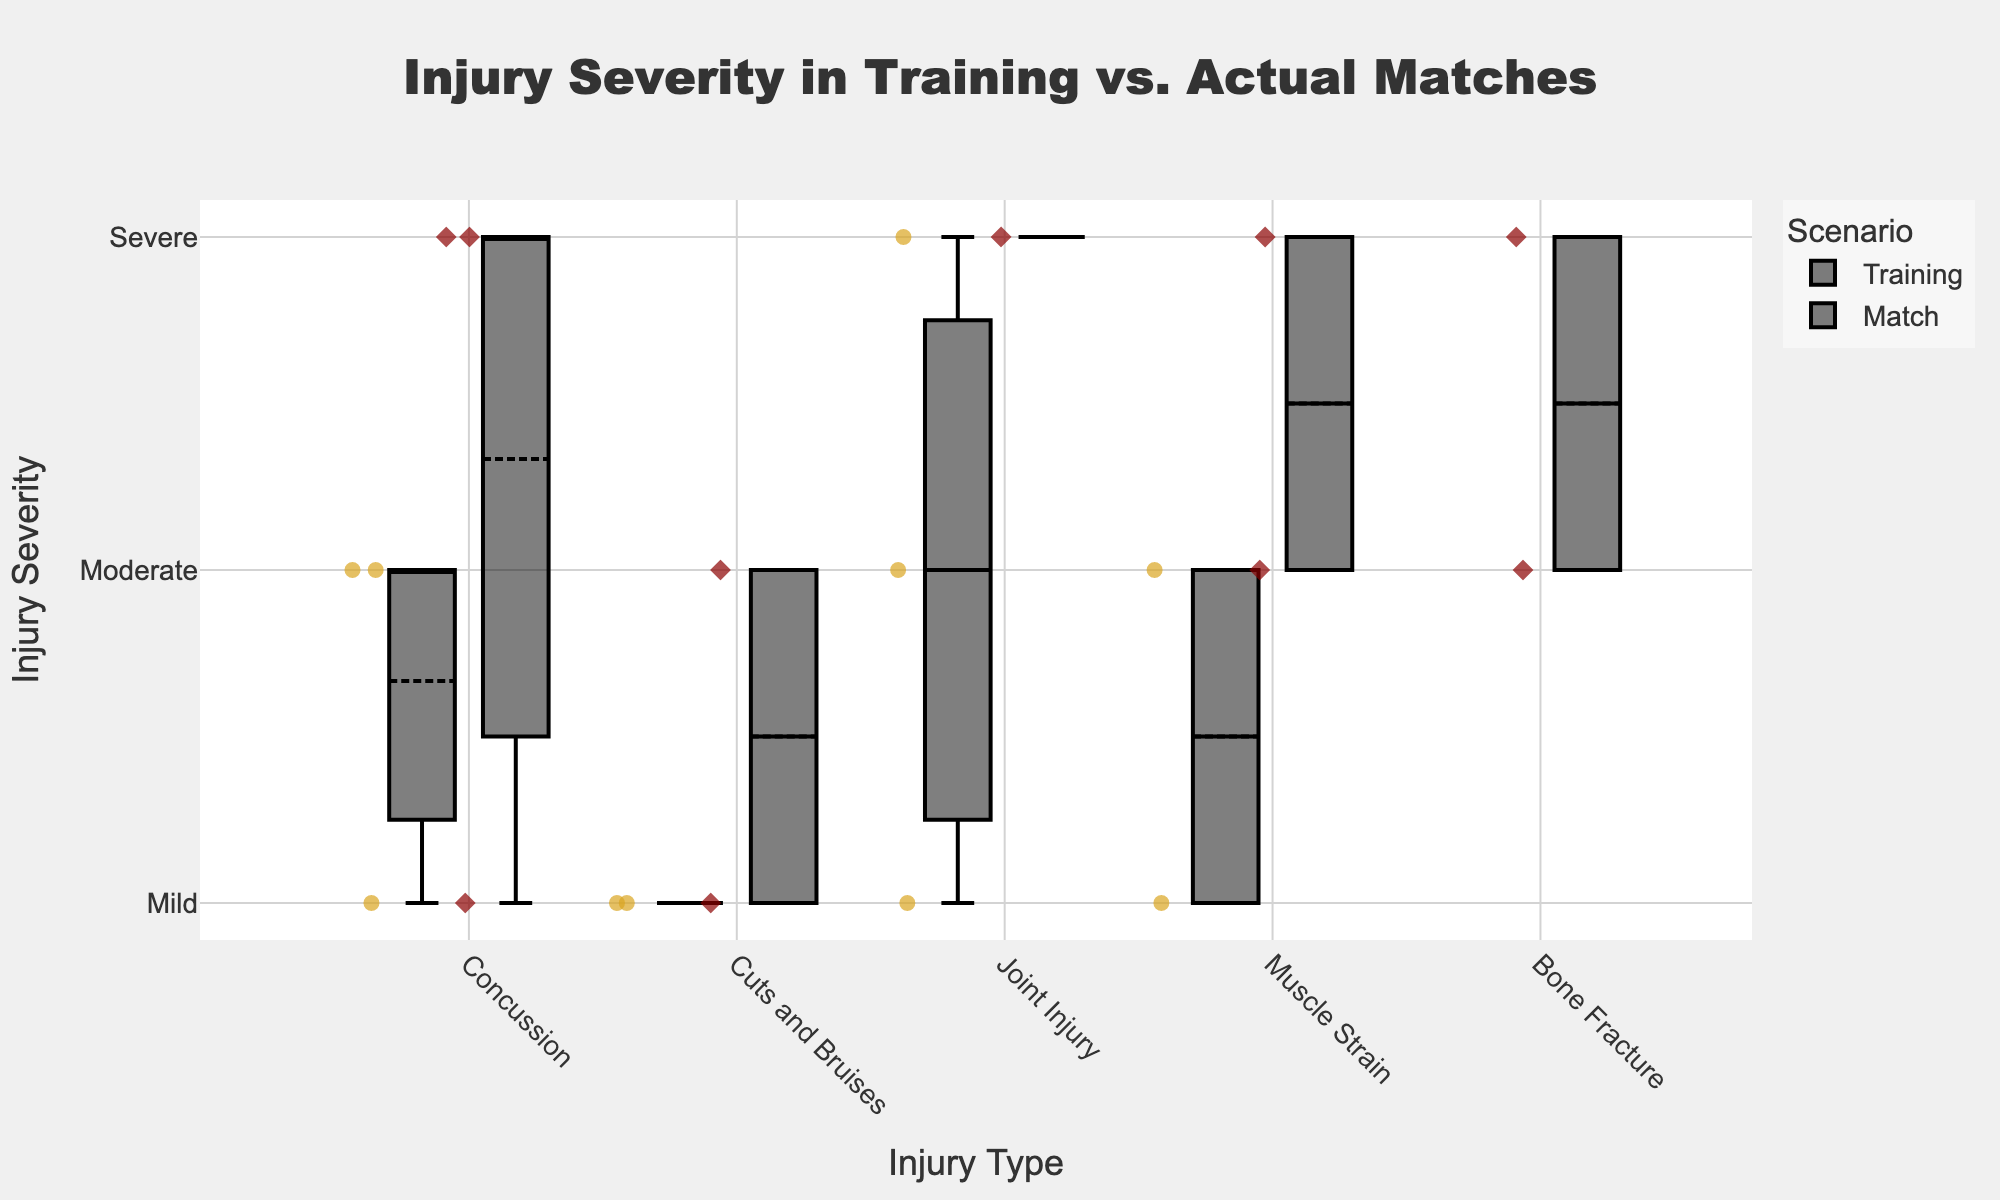What is the title of the plot? The title is displayed at the top of the figure, highlighting the main focus.
Answer: "Injury Severity in Training vs. Actual Matches" Which scenario has more data points for "Concussion"? By examining the plot, count the number of points associated with each scenario under "Concussion". Training has more points.
Answer: Training What color represents the "Match" scenario? By analyzing the color legend, identify the color linked to the "Match" scenario.
Answer: Dark red How does the severity of "Muscle Strain" compare between Training and Match scenarios? Look at the distribution of "Muscle Strain" severity levels for both scenarios. Training scenario has more mild and moderate injuries compared to the match scenario, where there's a mix of moderate and severe injuries.
Answer: Training has milder injuries Which injury type shows the most variation in severity for matches? Identify the injury type with the widest spread or range in severity levels in the "Match" scenario. For matches, "Muscle Strain" and "Joint Injury" both have a wide spread, extending from mild to severe injuries.
Answer: Muscle Strain and Joint Injury How many data points are there for "Bone Fracture" in matches? Count the individual data points under "Bone Fracture" in the match scenario. There are two data points here.
Answer: Two Which injury severity level appears most frequently in trainings? Observe the box plot for the training scenario and note which severity level has the highest frequency. "Moderate" injuries appear most frequently.
Answer: Moderate What is the median injury severity for "Cuts and Bruises" in trainings? The median is represented by the central line in the box plot for "Cuts and Bruises" in the training scenario. The median severity is "Mild."
Answer: Mild Which injury type has matching severity levels in both scenarios? Compare severity levels for each injury type between the two scenarios to see if there’s an overlap. "Concussion" and "Cuts and Bruises" match at "Mild," and "Joint Injury" matches at "Severe" levels across both scenarios.
Answer: Concussion, Cuts and Bruises, Joint Injury 